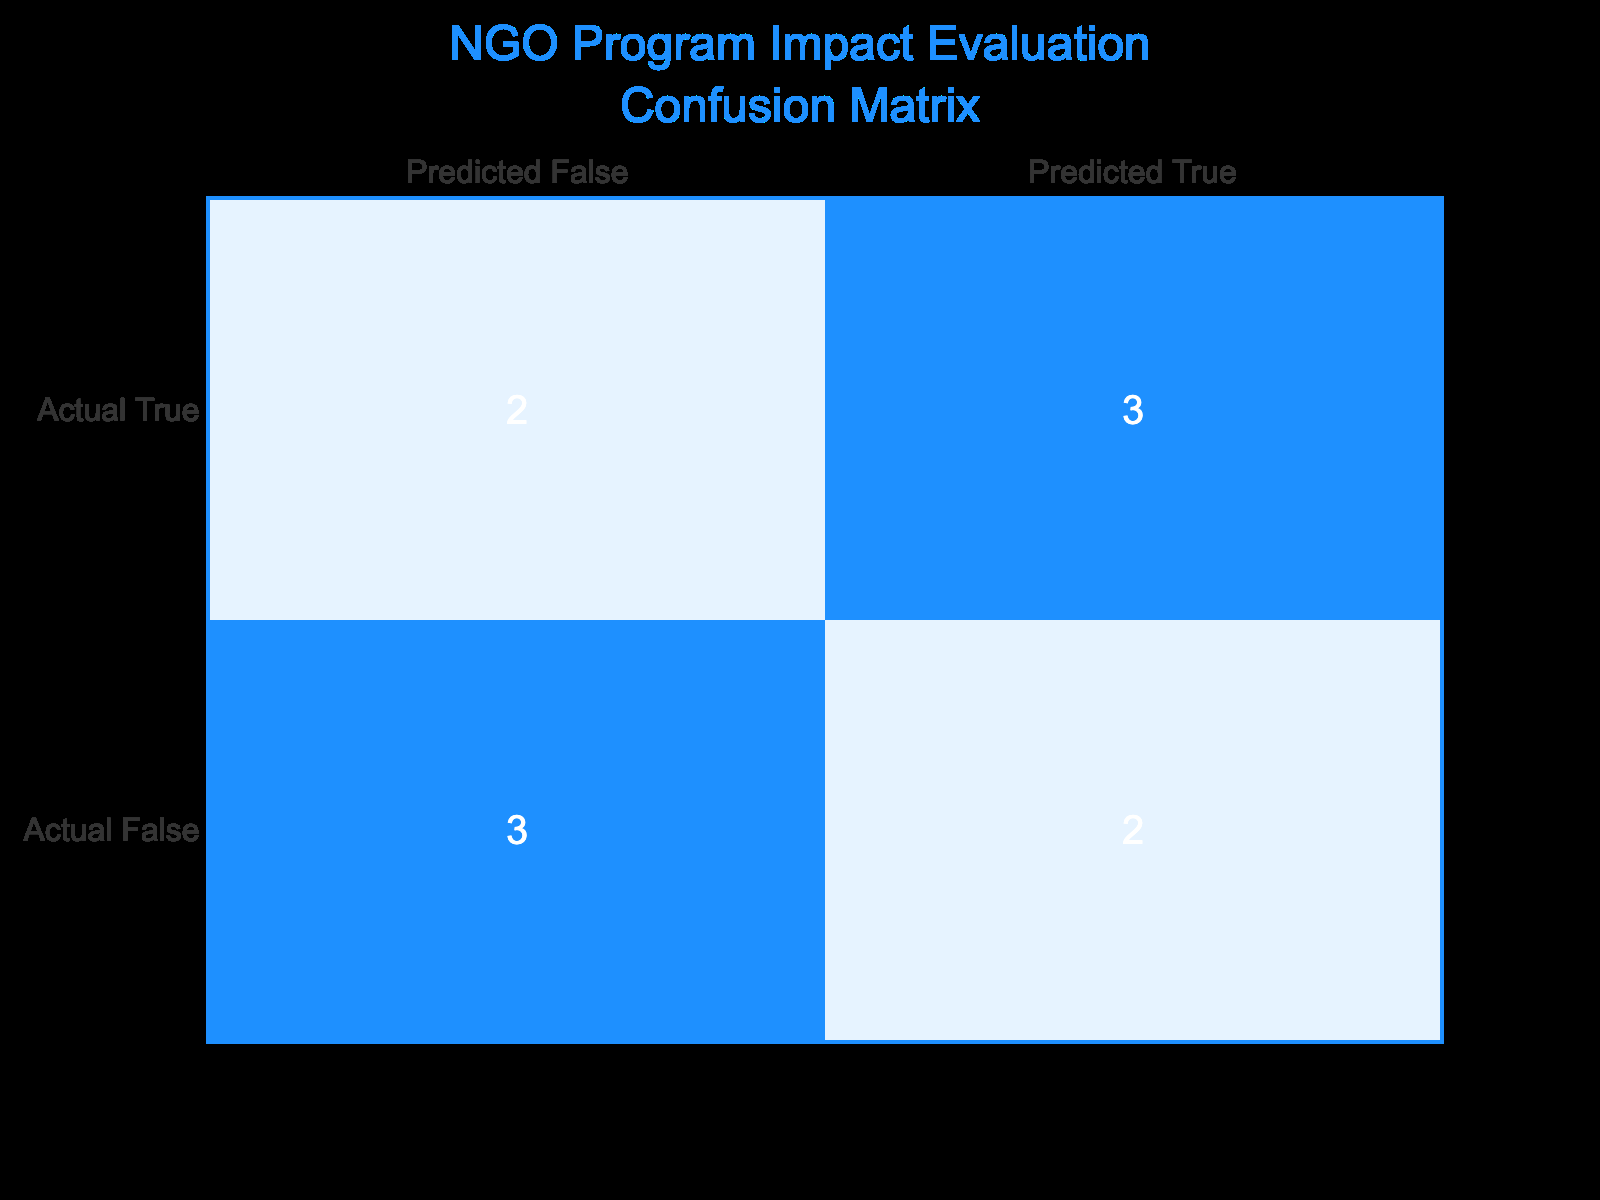What is the total number of instances where the predicted outcome was "True"? To find the total instances of predicted outcomes being "True," we need to look at the "Predicted True" column of the confusion matrix. There are 5 instances where the predicted outcome was "True" (3 True positives and 2 False positives).
Answer: 5 How many instances were actually successful (actual outcomes are "True")? To determine the actual successes, we check the "Actual True" row of the confusion matrix. There are 5 instances where the actual outcome was "True" (3 True positives and 2 False negatives).
Answer: 5 What percentage of the total predictions were correct? To calculate the percentage of correct predictions, we sum the True Positives (3) and True Negatives (2), which gives us a total of 5 correct predictions. The total number of predictions is 10. Thus, the percentage is (5/10) * 100 = 50%.
Answer: 50% Were there more instances of False negatives than True negatives? To answer this question, we compare the number of False negatives (2) to the number of True negatives (2). Since they are equal, the statement is not true.
Answer: No What is the ratio of True positives to False positives? To find the ratio, we identify the True positives (3) and False positives (2). The ratio is 3:2, meaning for every 3 successful predictions, there are 2 incorrect predictions.
Answer: 3:2 How many more True positives are there compared to False negatives? We compare the number of True positives (3) with False negatives (2). The difference is 3 - 2 = 1, indicating that there is 1 more True positive than False negative.
Answer: 1 If a new instance is predicted as "False," what is the probability that it is actually successful? To find this probability, we take the number of True negatives (2) and divide it by the total instances predicted as "False" (False positives 2 + True negatives 2 = 4). Hence, the probability is 2/4 = 0.5 or 50%.
Answer: 50% What is the total count of incorrect predictions? The total incorrect predictions are the sum of False positives (2) and False negatives (2). Therefore, the total count of incorrect predictions is 2 + 2 = 4.
Answer: 4 How many more instances were predicted as False than True? We look at the counts for predicted outcomes: Predicted False (4) and Predicted True (5). The difference is 5 - 4 = -1, meaning 1 instance fewer was predicted as False compared to True.
Answer: 1 fewer What is the proportion of actual failures to total instances? The total instances are 10. Actual failures (False) consists of False positives (2) and True negatives (2), totaling 4. Therefore, the proportion is 4/10 = 0.4 or 40%.
Answer: 40% 